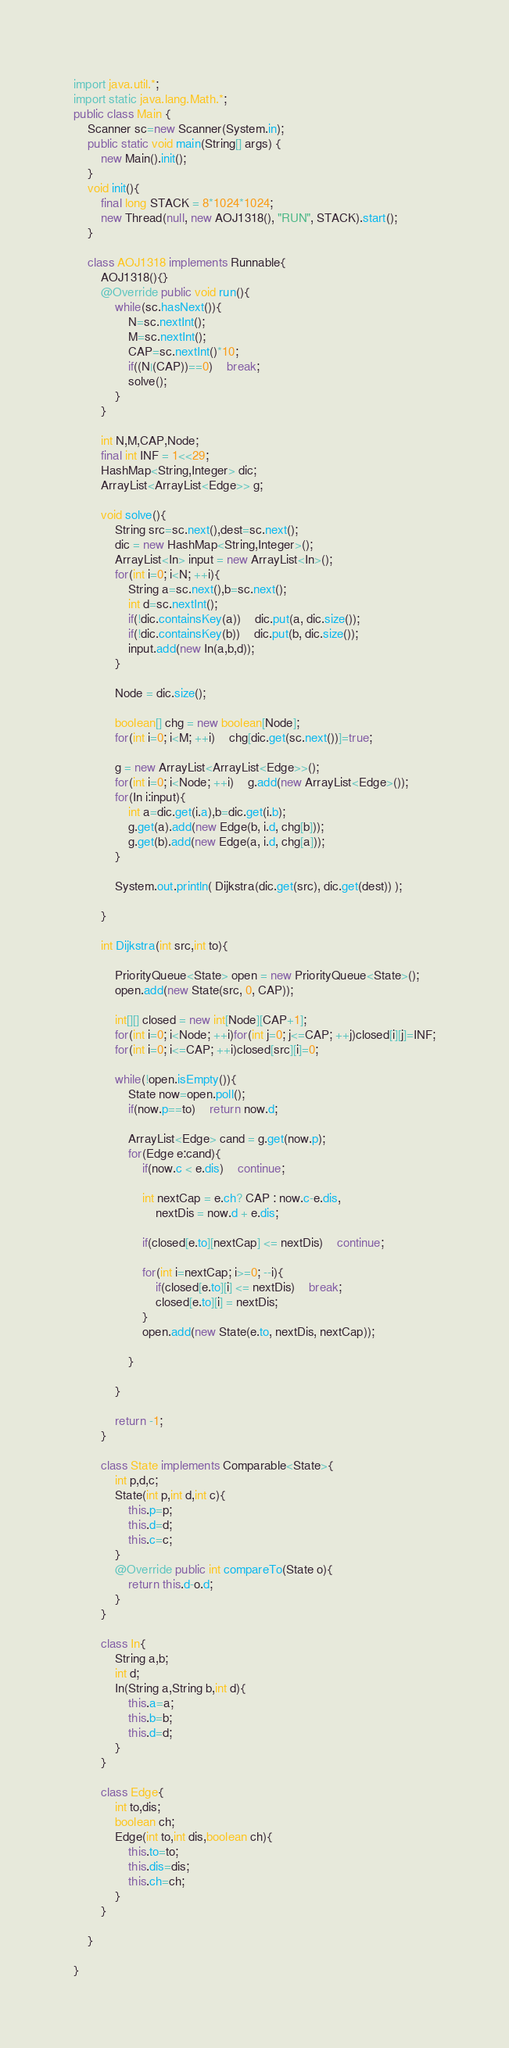<code> <loc_0><loc_0><loc_500><loc_500><_Java_>import java.util.*;
import static java.lang.Math.*;
public class Main {
	Scanner sc=new Scanner(System.in);
	public static void main(String[] args) {
		new Main().init();
	}
	void init(){
		final long STACK = 8*1024*1024;
		new Thread(null, new AOJ1318(), "RUN", STACK).start();
	}
	
	class AOJ1318 implements Runnable{
		AOJ1318(){}
		@Override public void run(){
			while(sc.hasNext()){
				N=sc.nextInt();
				M=sc.nextInt();
				CAP=sc.nextInt()*10;
				if((N|(CAP))==0)	break;
				solve();
			}
		}
		
		int N,M,CAP,Node;
		final int INF = 1<<29;
		HashMap<String,Integer> dic;
		ArrayList<ArrayList<Edge>> g;
		
		void solve(){
			String src=sc.next(),dest=sc.next();
			dic = new HashMap<String,Integer>();
			ArrayList<In> input = new ArrayList<In>();
			for(int i=0; i<N; ++i){
				String a=sc.next(),b=sc.next();
				int d=sc.nextInt();
				if(!dic.containsKey(a))	dic.put(a, dic.size());
				if(!dic.containsKey(b))	dic.put(b, dic.size());
				input.add(new In(a,b,d));
			}
			
			Node = dic.size();
			
			boolean[] chg = new boolean[Node];
			for(int i=0; i<M; ++i)	chg[dic.get(sc.next())]=true;
			
			g = new ArrayList<ArrayList<Edge>>();
			for(int i=0; i<Node; ++i)	g.add(new ArrayList<Edge>());
			for(In i:input){
				int a=dic.get(i.a),b=dic.get(i.b);
				g.get(a).add(new Edge(b, i.d, chg[b]));
				g.get(b).add(new Edge(a, i.d, chg[a]));
			}
			
			System.out.println( Dijkstra(dic.get(src), dic.get(dest)) );
			
		}
		
		int Dijkstra(int src,int to){
			
			PriorityQueue<State> open = new PriorityQueue<State>();
			open.add(new State(src, 0, CAP));
			
			int[][] closed = new int[Node][CAP+1];
			for(int i=0; i<Node; ++i)for(int j=0; j<=CAP; ++j)closed[i][j]=INF;
			for(int i=0; i<=CAP; ++i)closed[src][i]=0;
			
			while(!open.isEmpty()){
				State now=open.poll();
				if(now.p==to)	return now.d;
				
				ArrayList<Edge> cand = g.get(now.p);
				for(Edge e:cand){
					if(now.c < e.dis)	continue;
					
					int nextCap = e.ch? CAP : now.c-e.dis,
						nextDis = now.d + e.dis;
					
					if(closed[e.to][nextCap] <= nextDis)	continue;
					
					for(int i=nextCap; i>=0; --i){
						if(closed[e.to][i] <= nextDis)	break;
						closed[e.to][i] = nextDis;
					}
					open.add(new State(e.to, nextDis, nextCap));
					
				}
				
			}
			
			return -1;
		}
		
		class State implements Comparable<State>{
			int p,d,c;
			State(int p,int d,int c){
				this.p=p;
				this.d=d;
				this.c=c;
			}
			@Override public int compareTo(State o){
				return this.d-o.d;
			}
		}
		
		class In{
			String a,b;
			int d;
			In(String a,String b,int d){
				this.a=a;
				this.b=b;
				this.d=d;
			}
		}
		
		class Edge{
			int to,dis;
			boolean ch;
			Edge(int to,int dis,boolean ch){
				this.to=to;
				this.dis=dis;
				this.ch=ch;
			}
		}
		
	}

}</code> 